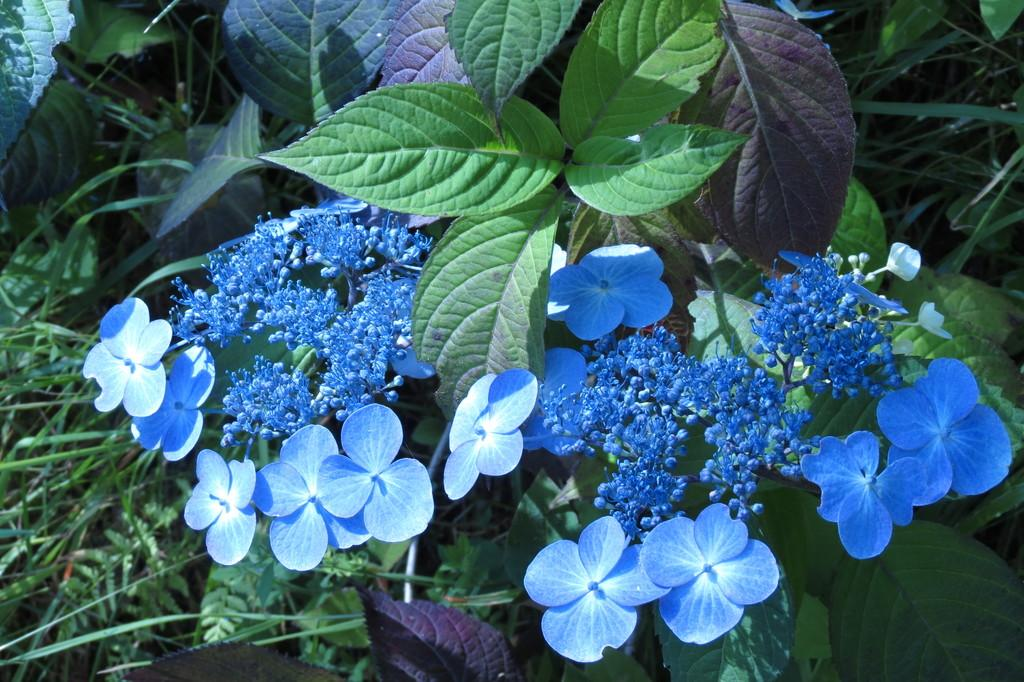What type of living organisms can be seen in the image? Plants can be seen in the image. What color are the flowers on the plants? The flowers on the plants are blue. What part of the plants is visible in the image? Leaves are present on the plants. How many cars are parked next to the plants in the image? There are no cars present in the image; it only features plants with blue flowers and leaves. 